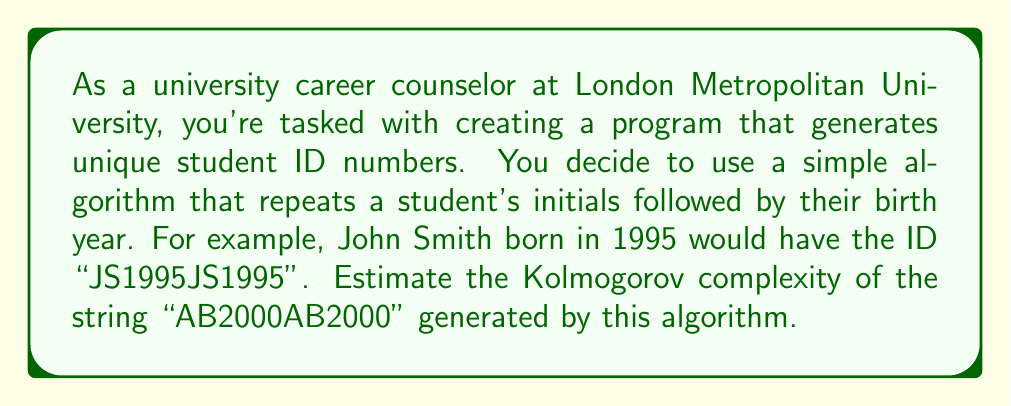Could you help me with this problem? To estimate the Kolmogorov complexity of the given string, we need to consider the shortest possible program that could generate this string. Let's break it down step by step:

1) The string "AB2000AB2000" has a clear pattern: it's a repetition of "AB2000".

2) To generate this string, we need a program that:
   a) Stores the substring "AB2000"
   b) Repeats it twice

3) Let's estimate the bits required for each part:
   a) Storing "AB2000":
      - 'A' and 'B' each require 8 bits (1 byte) in ASCII: 2 * 8 = 16 bits
      - '2000' requires 4 bytes: 4 * 8 = 32 bits
      Total for substring: 16 + 32 = 48 bits

   b) Instructions to repeat the substring:
      - This could be done with a simple loop, which might require about 8-16 bits to encode

4) Additional overhead:
   - We might need a few more bits for program structure, variable declarations, etc. Let's estimate this at 16 bits.

5) Total estimate:
   $$ K(s) \approx 48 + 16 + 16 = 80 \text{ bits} $$

This is significantly less than the length of the string itself (12 characters * 8 bits/character = 96 bits), indicating that the string has some compressibility due to its repetitive nature.

Note: This is an estimate. The actual Kolmogorov complexity could be slightly higher or lower depending on the specific programming language and encoding used.
Answer: The estimated Kolmogorov complexity of the string "AB2000AB2000" is approximately 80 bits. 